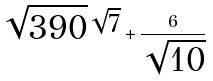Convert formula to latex. <formula><loc_0><loc_0><loc_500><loc_500>\sqrt { 3 9 0 } ^ { \sqrt { 7 } } + \frac { 6 } { \sqrt { 1 0 } }</formula> 